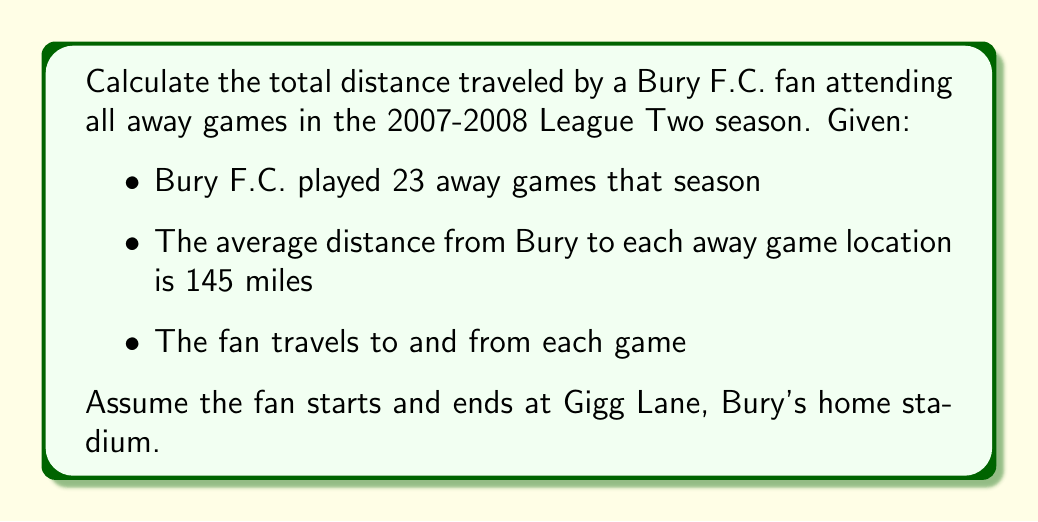Could you help me with this problem? To solve this problem, we need to follow these steps:

1. Calculate the distance for a single round trip:
   Let $d$ be the average distance to an away game.
   Round trip distance = $2d = 2 \times 145 = 290$ miles

2. Calculate the total distance for all away games:
   Let $n$ be the number of away games.
   Total distance = $n \times 2d = 23 \times 290 = 6670$ miles

The calculation can be represented by the formula:

$$\text{Total Distance} = n \times 2d$$

Where:
$n$ = number of away games = 23
$d$ = average distance to an away game = 145 miles

Substituting the values:

$$\text{Total Distance} = 23 \times 2 \times 145 = 6670 \text{ miles}$$

Therefore, the Bury F.C. fan would have traveled a total of 6,670 miles to attend all away games in the 2007-2008 season.
Answer: 6,670 miles 